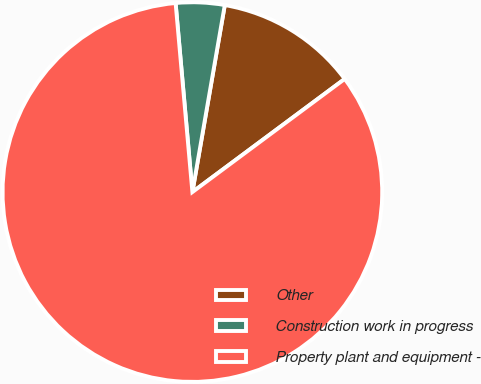Convert chart. <chart><loc_0><loc_0><loc_500><loc_500><pie_chart><fcel>Other<fcel>Construction work in progress<fcel>Property plant and equipment -<nl><fcel>12.1%<fcel>4.14%<fcel>83.75%<nl></chart> 